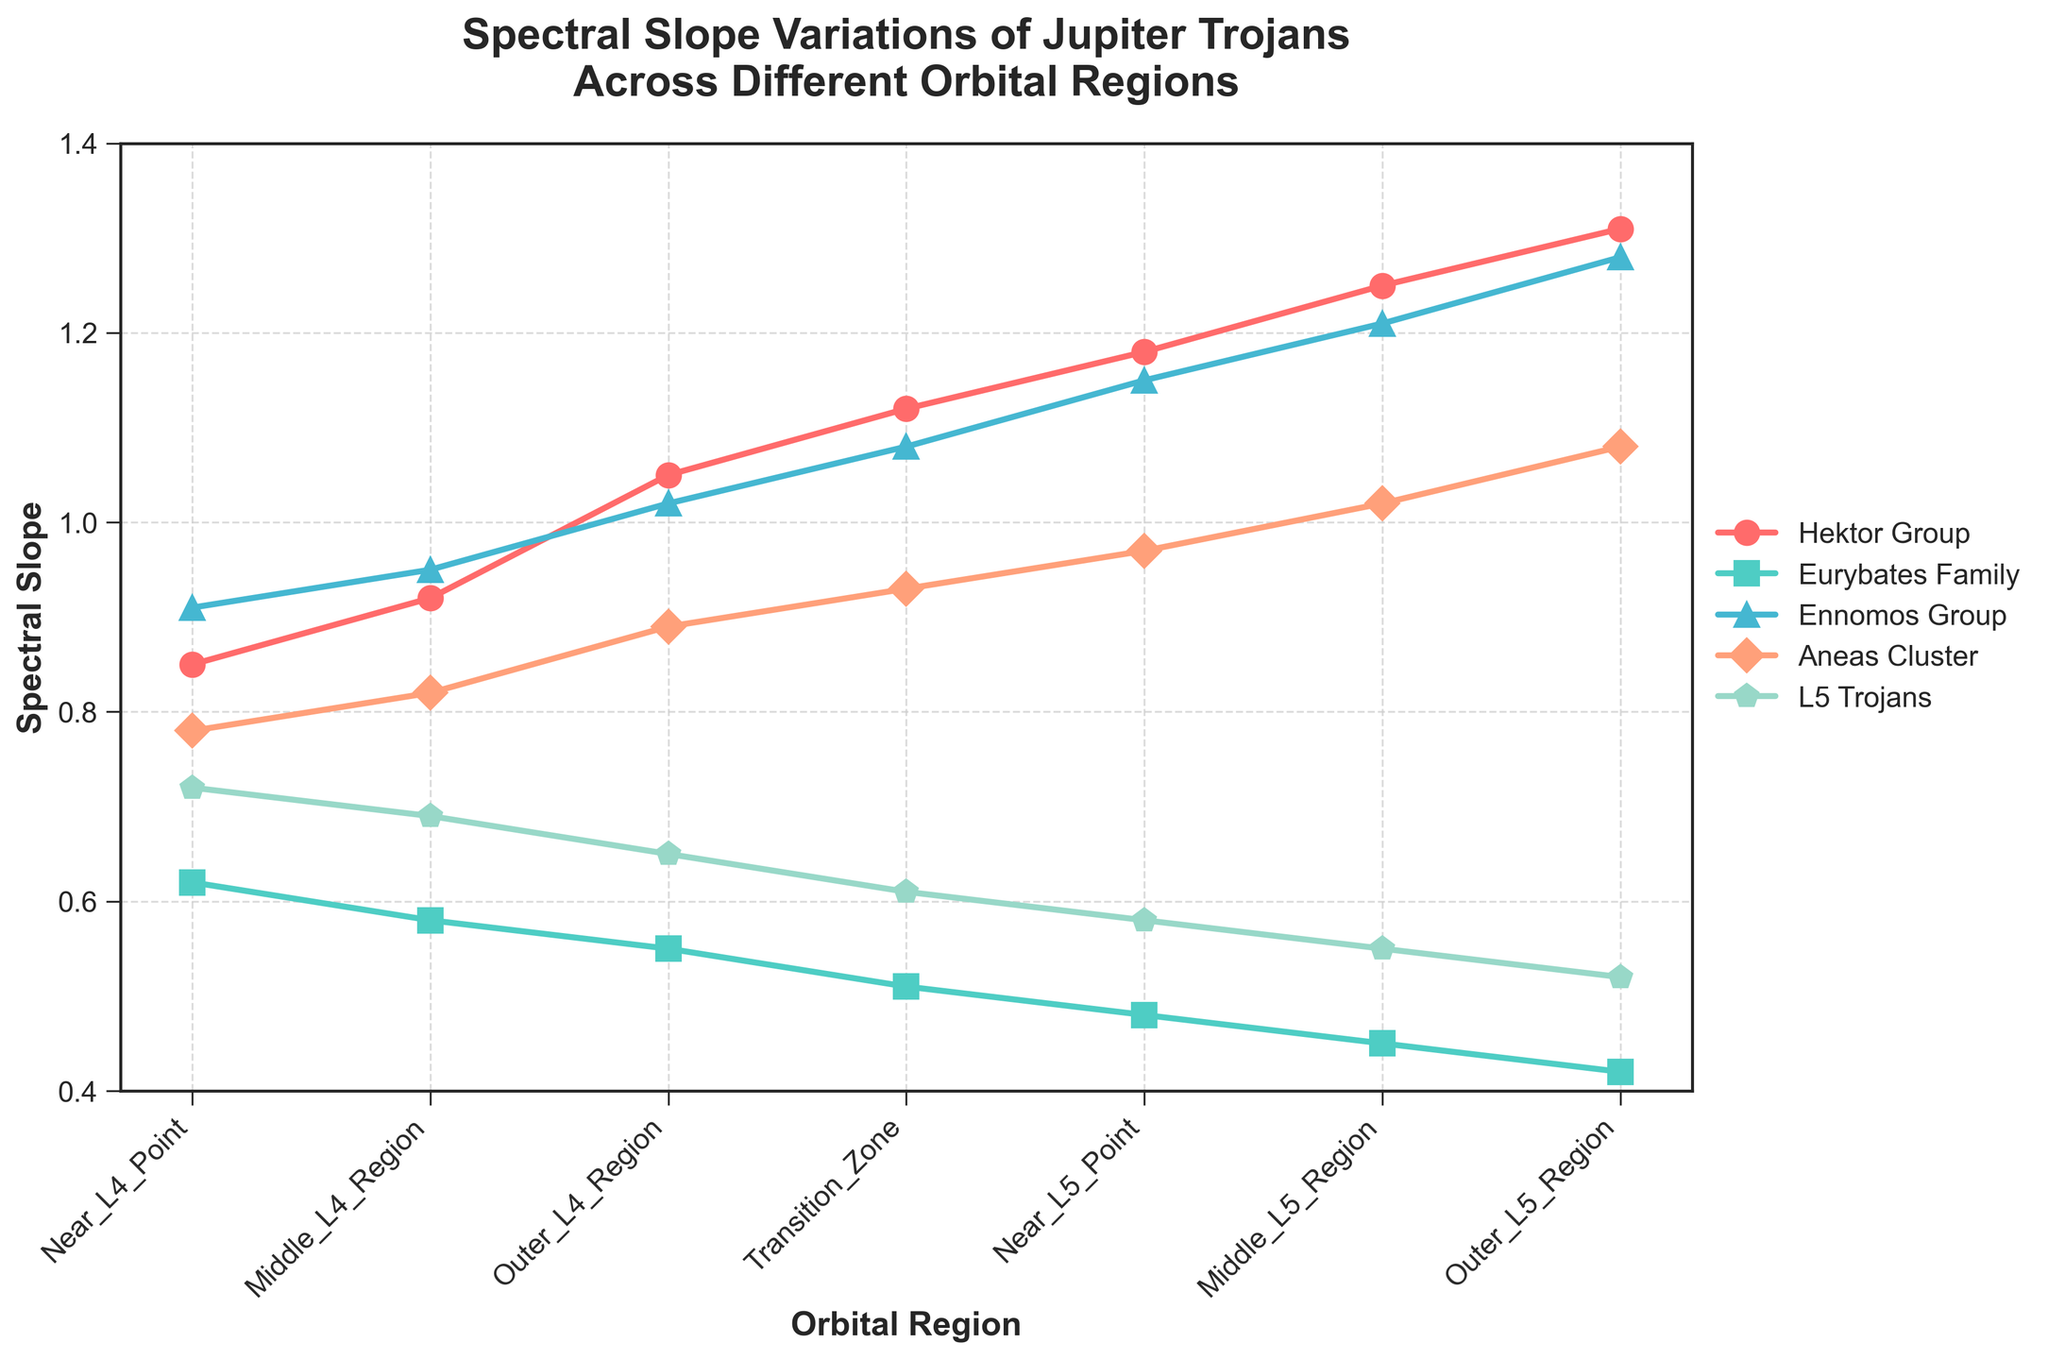Which orbital region shows the highest spectral slope for the Hektor group? Scan the line chart and locate the peak spectral slope value for the Hektor group. The Hektor group line (marked in red) peaks in the Outer L5 Region.
Answer: Outer L5 Region How does the spectral slope of the Ennomos group change from the Near L4 Point to the Outer L5 Region? Observe the line chart. The Ennomos group line (marked in green) shows an increasing trend from 0.91 at Near L4 Point to 1.28 at Outer L5 Region.
Answer: Increases Which group exhibits the smallest change in spectral slope across all orbital regions? Check the steepness of each group's line. Smaller slope change means a flatter line. The Eurybates Family (marked in blue) shows the flattest trend, changing from 0.62 to 0.42.
Answer: Eurybates Family What is the difference in spectral slope between the Aneas Cluster and L5 Trojans in the Middle L4 Region? Locate the Middle L4 Region and subtract the L5 Trojans value (0.69) from the Aneas Cluster value (0.82). 0.82 - 0.69 = 0.13
Answer: 0.13 Which group has the steepest increase in spectral slope from the Near L4 Point to the Near L5 Point? Compare the slopes of all groups between these regions. The Hektor Group (marked in red) has the largest difference: 1.18 - 0.85 = 0.33.
Answer: Hektor Group What is the average spectral slope of the L5 Trojans across all orbital regions? Add the L5 Trojans spectral slope values and divide by the number of regions: (0.72 + 0.69 + 0.65 + 0.61 + 0.58 + 0.55 + 0.52) / 7 = 0.61.
Answer: 0.61 In which orbital region is the difference between the Hektor Group and Eurybates Family the largest? Calculate the difference for each region and find the largest: 
Near L4 = 0.85 - 0.62 = 0.23,
Middle L4 = 0.92 - 0.58 = 0.34,
Outer L4 = 1.05 - 0.55 = 0.50,
Transition Zone = 1.12 - 0.51 = 0.61,
Near L5 = 1.18 - 0.48 = 0.70,
Middle L5 = 1.25 - 0.45 = 0.80,
Outer L5 = 1.31 - 0.42 = 0.89.
The largest difference is in the Outer L5 Region: 0.89.
Answer: Outer L5 Region Which group has the lowest spectral slope in the Near L4 Point and what is its value? Look at the spectral slope values at Near L4 Point and find the minimum. The Eurybates Family group (marked in blue) has the lowest value of 0.62.
Answer: Eurybates Family, 0.62 